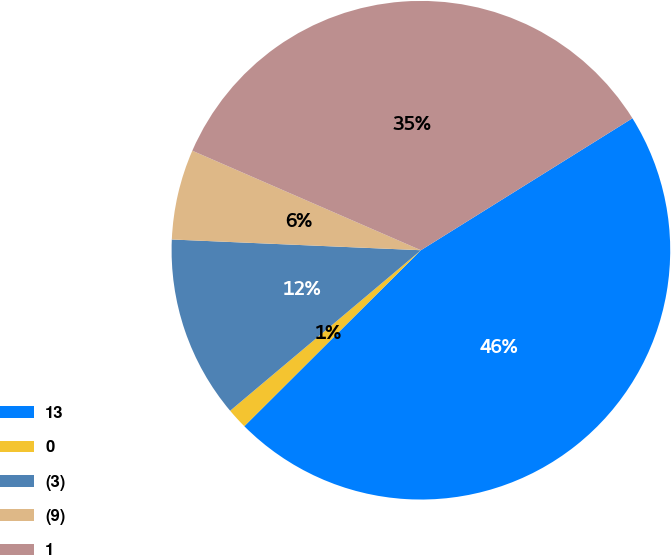Convert chart to OTSL. <chart><loc_0><loc_0><loc_500><loc_500><pie_chart><fcel>13<fcel>0<fcel>(3)<fcel>(9)<fcel>1<nl><fcel>46.41%<fcel>1.34%<fcel>11.82%<fcel>5.85%<fcel>34.59%<nl></chart> 